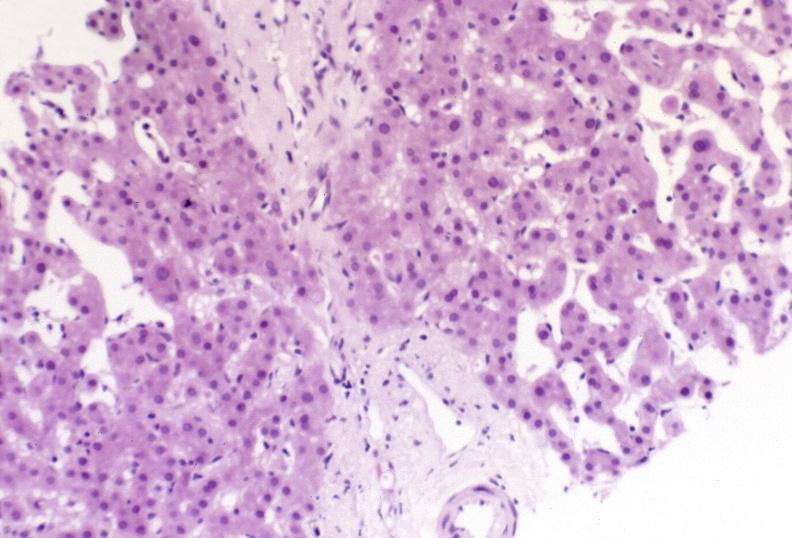s endometritis postpartum present?
Answer the question using a single word or phrase. No 